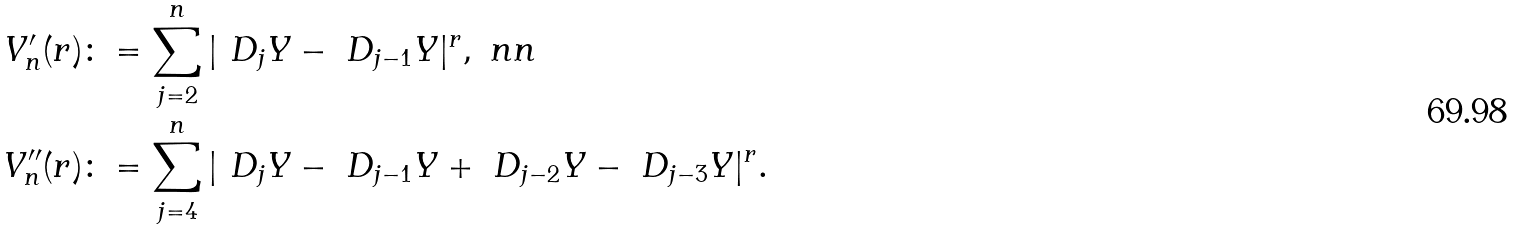<formula> <loc_0><loc_0><loc_500><loc_500>V ^ { \prime } _ { n } ( r ) & \colon = \sum _ { j = 2 } ^ { n } | \ D _ { j } Y - \ D _ { j - 1 } Y | ^ { r } , \ n n \\ V ^ { \prime \prime } _ { n } ( r ) & \colon = \sum _ { j = 4 } ^ { n } | \ D _ { j } Y - \ D _ { j - 1 } Y + \ D _ { j - 2 } Y - \ D _ { j - 3 } Y | ^ { r } .</formula> 